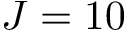Convert formula to latex. <formula><loc_0><loc_0><loc_500><loc_500>J = 1 0</formula> 